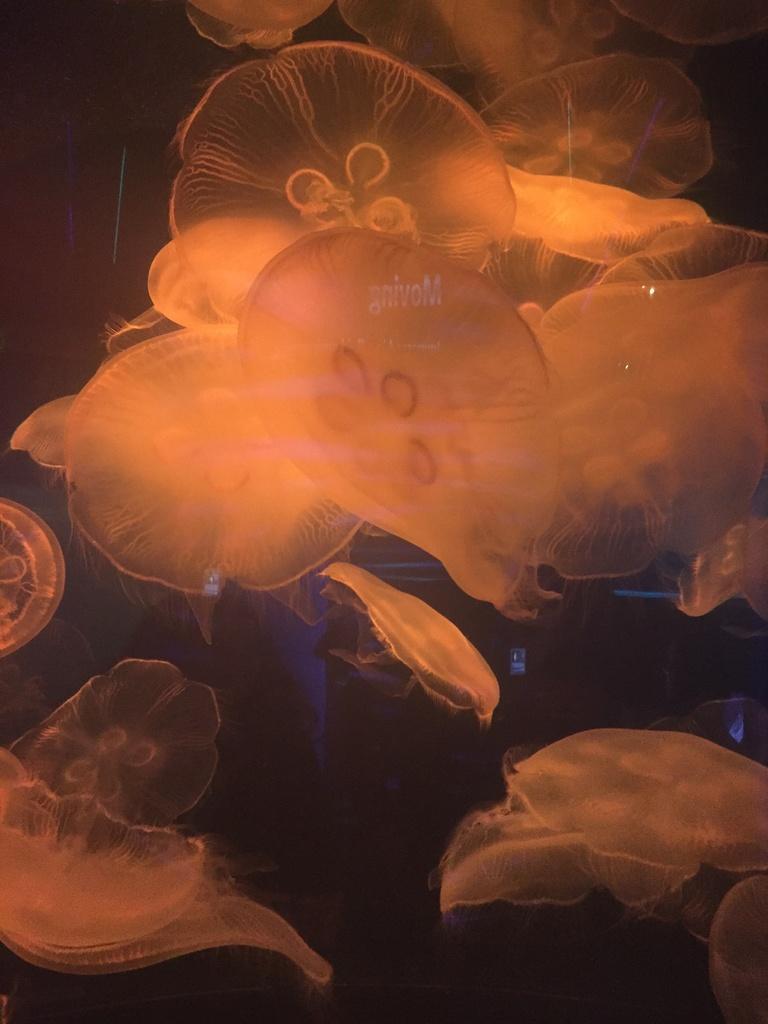Describe this image in one or two sentences. In this picture we can see jellyfishes. 